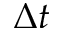<formula> <loc_0><loc_0><loc_500><loc_500>\Delta t</formula> 